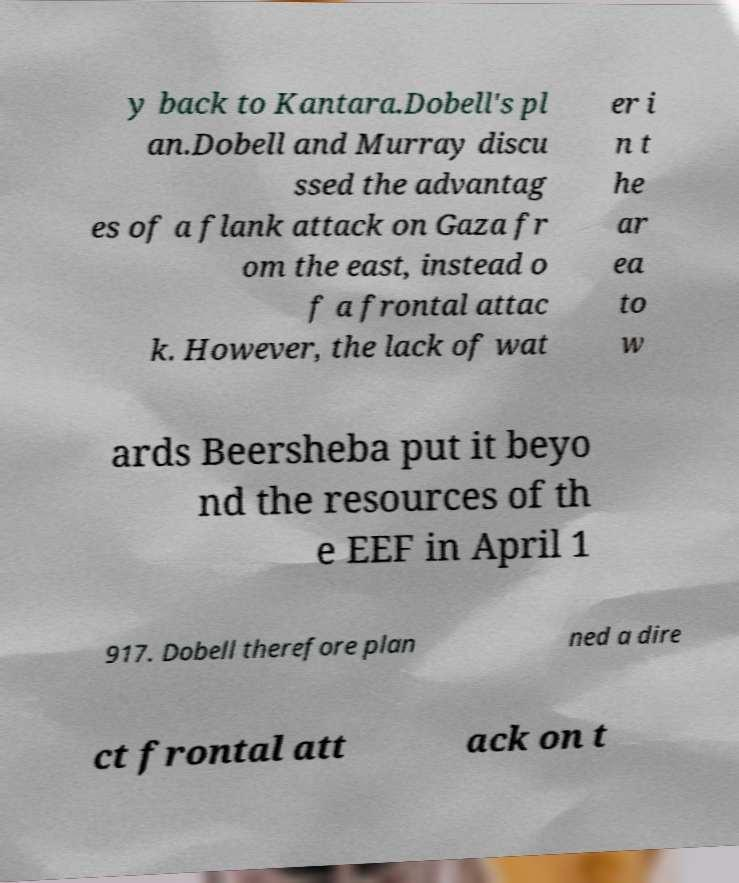Can you read and provide the text displayed in the image?This photo seems to have some interesting text. Can you extract and type it out for me? y back to Kantara.Dobell's pl an.Dobell and Murray discu ssed the advantag es of a flank attack on Gaza fr om the east, instead o f a frontal attac k. However, the lack of wat er i n t he ar ea to w ards Beersheba put it beyo nd the resources of th e EEF in April 1 917. Dobell therefore plan ned a dire ct frontal att ack on t 